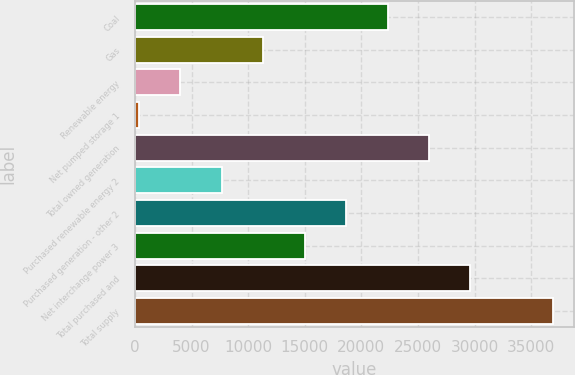Convert chart to OTSL. <chart><loc_0><loc_0><loc_500><loc_500><bar_chart><fcel>Coal<fcel>Gas<fcel>Renewable energy<fcel>Net pumped storage 1<fcel>Total owned generation<fcel>Purchased renewable energy 2<fcel>Purchased generation - other 2<fcel>Net interchange power 3<fcel>Total purchased and<fcel>Total supply<nl><fcel>22313.6<fcel>11339.3<fcel>4023.1<fcel>365<fcel>25971.7<fcel>7681.2<fcel>18655.5<fcel>14997.4<fcel>29629.8<fcel>36946<nl></chart> 